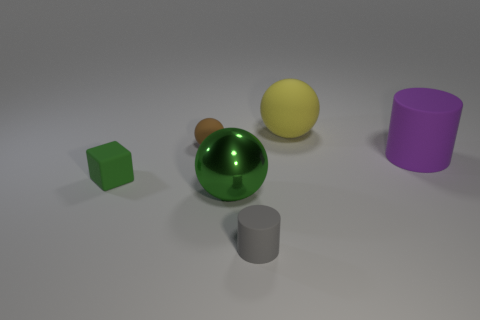Which objects are closest to the foreground of the image? The objects closest to the foreground are the green cube on the left and the grey cylinder in the center. They appear larger and have a more distinct shadow, indicating their proximity to the viewpoint. 